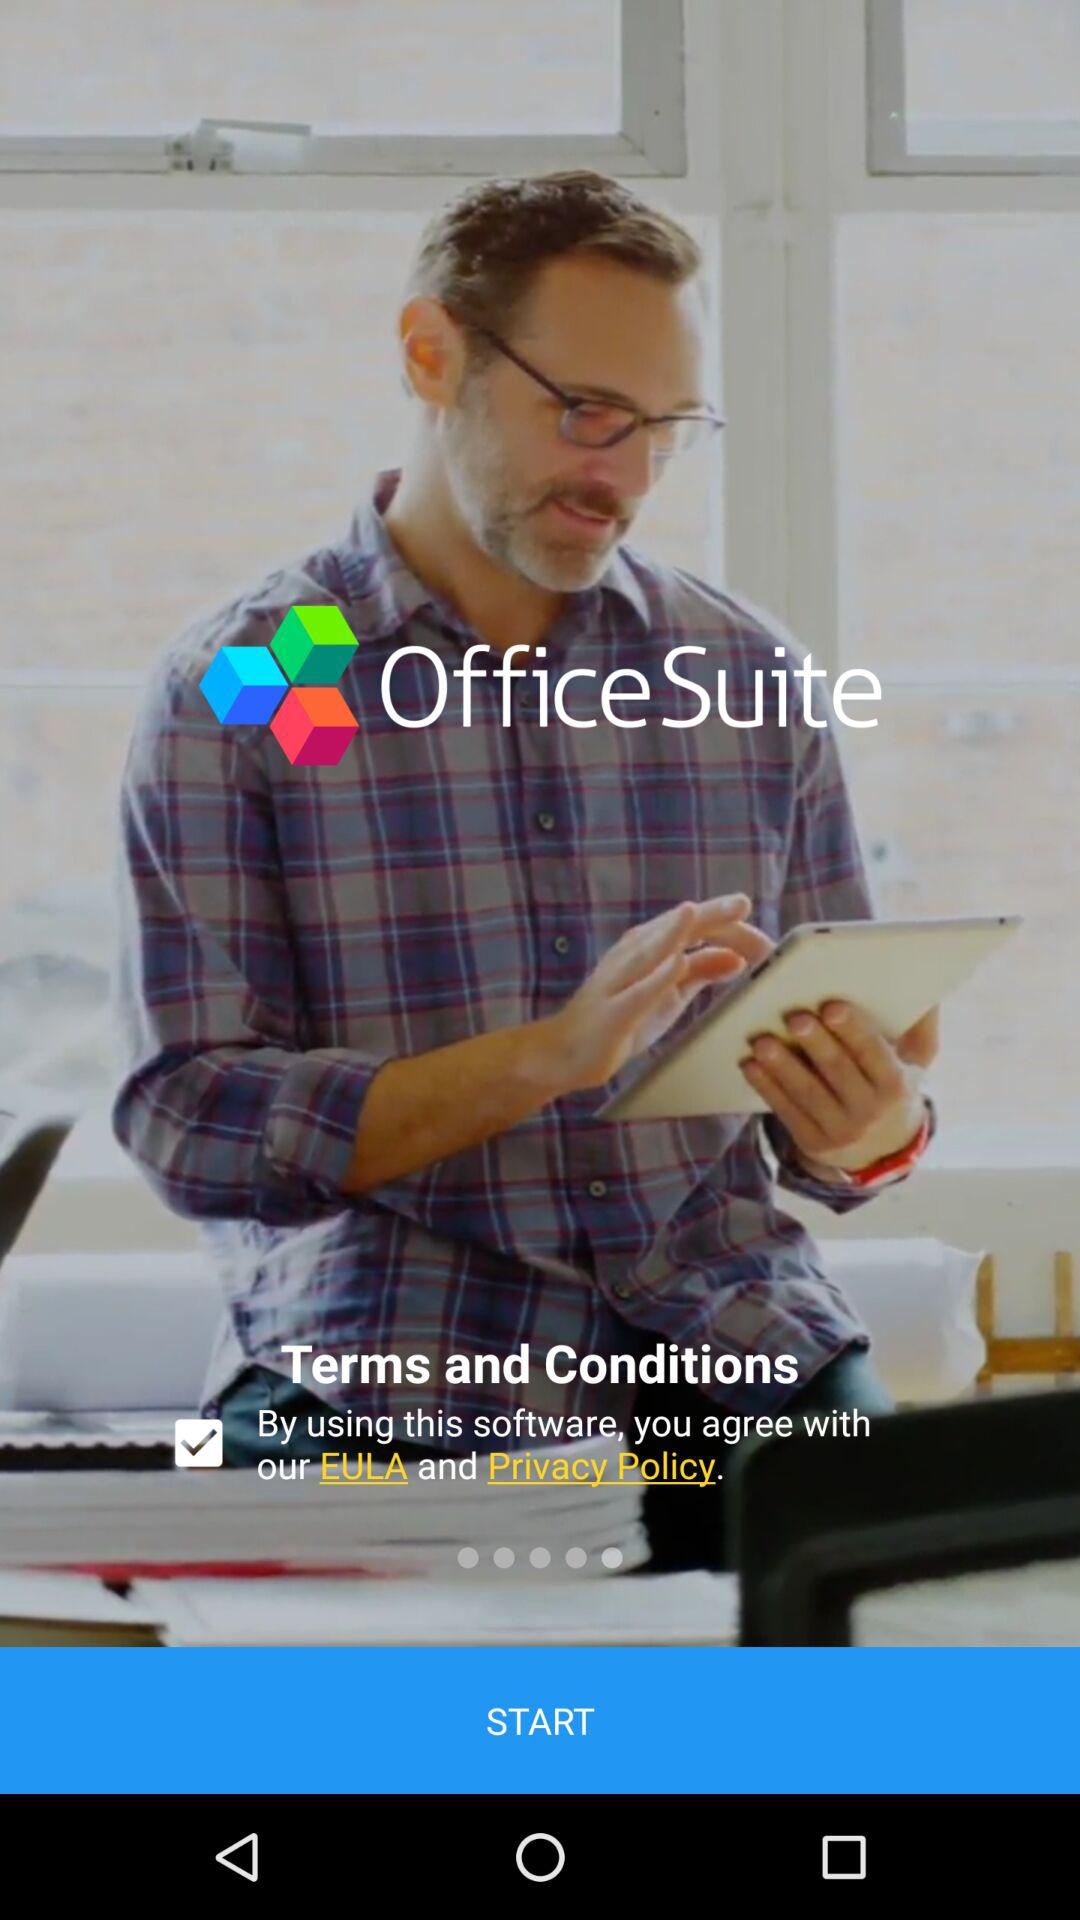What is the description of the "EULA"?
When the provided information is insufficient, respond with <no answer>. <no answer> 